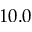<formula> <loc_0><loc_0><loc_500><loc_500>1 0 . 0</formula> 